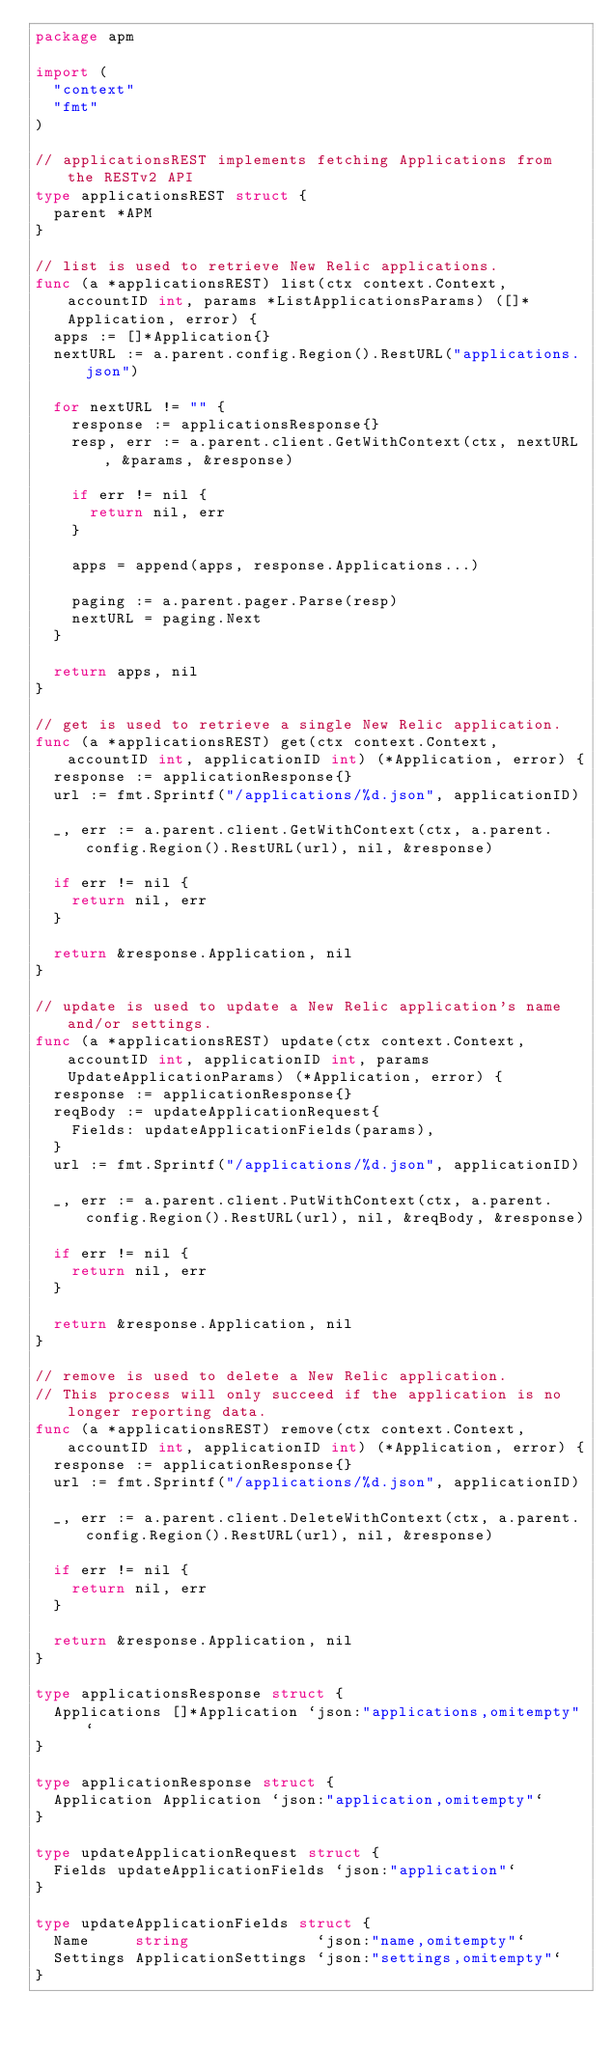Convert code to text. <code><loc_0><loc_0><loc_500><loc_500><_Go_>package apm

import (
	"context"
	"fmt"
)

// applicationsREST implements fetching Applications from the RESTv2 API
type applicationsREST struct {
	parent *APM
}

// list is used to retrieve New Relic applications.
func (a *applicationsREST) list(ctx context.Context, accountID int, params *ListApplicationsParams) ([]*Application, error) {
	apps := []*Application{}
	nextURL := a.parent.config.Region().RestURL("applications.json")

	for nextURL != "" {
		response := applicationsResponse{}
		resp, err := a.parent.client.GetWithContext(ctx, nextURL, &params, &response)

		if err != nil {
			return nil, err
		}

		apps = append(apps, response.Applications...)

		paging := a.parent.pager.Parse(resp)
		nextURL = paging.Next
	}

	return apps, nil
}

// get is used to retrieve a single New Relic application.
func (a *applicationsREST) get(ctx context.Context, accountID int, applicationID int) (*Application, error) {
	response := applicationResponse{}
	url := fmt.Sprintf("/applications/%d.json", applicationID)

	_, err := a.parent.client.GetWithContext(ctx, a.parent.config.Region().RestURL(url), nil, &response)

	if err != nil {
		return nil, err
	}

	return &response.Application, nil
}

// update is used to update a New Relic application's name and/or settings.
func (a *applicationsREST) update(ctx context.Context, accountID int, applicationID int, params UpdateApplicationParams) (*Application, error) {
	response := applicationResponse{}
	reqBody := updateApplicationRequest{
		Fields: updateApplicationFields(params),
	}
	url := fmt.Sprintf("/applications/%d.json", applicationID)

	_, err := a.parent.client.PutWithContext(ctx, a.parent.config.Region().RestURL(url), nil, &reqBody, &response)

	if err != nil {
		return nil, err
	}

	return &response.Application, nil
}

// remove is used to delete a New Relic application.
// This process will only succeed if the application is no longer reporting data.
func (a *applicationsREST) remove(ctx context.Context, accountID int, applicationID int) (*Application, error) {
	response := applicationResponse{}
	url := fmt.Sprintf("/applications/%d.json", applicationID)

	_, err := a.parent.client.DeleteWithContext(ctx, a.parent.config.Region().RestURL(url), nil, &response)

	if err != nil {
		return nil, err
	}

	return &response.Application, nil
}

type applicationsResponse struct {
	Applications []*Application `json:"applications,omitempty"`
}

type applicationResponse struct {
	Application Application `json:"application,omitempty"`
}

type updateApplicationRequest struct {
	Fields updateApplicationFields `json:"application"`
}

type updateApplicationFields struct {
	Name     string              `json:"name,omitempty"`
	Settings ApplicationSettings `json:"settings,omitempty"`
}
</code> 